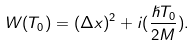Convert formula to latex. <formula><loc_0><loc_0><loc_500><loc_500>W ( T _ { 0 } ) = ( \Delta x ) ^ { 2 } + i ( \frac { \hslash T _ { 0 } } { 2 M } ) .</formula> 